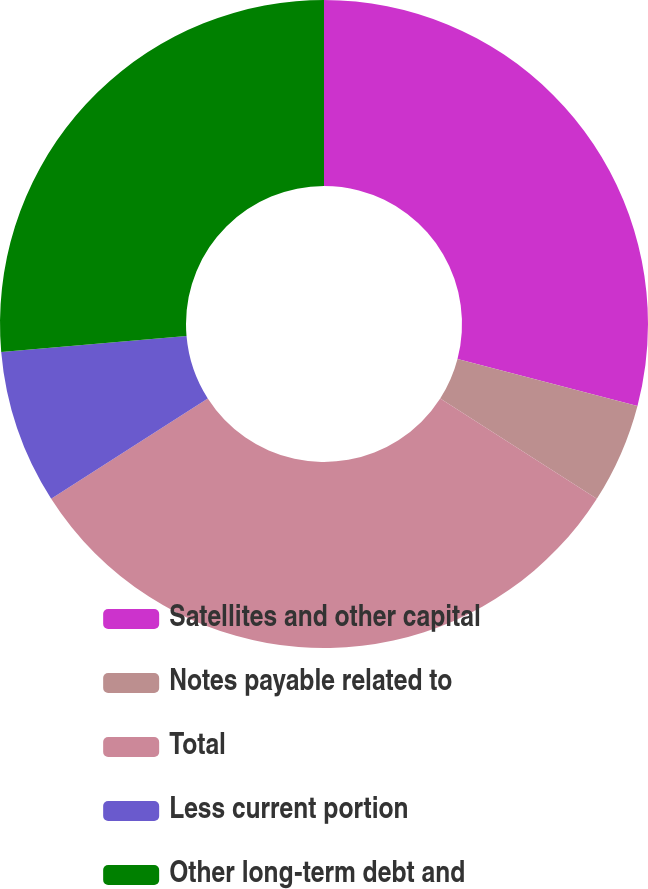<chart> <loc_0><loc_0><loc_500><loc_500><pie_chart><fcel>Satellites and other capital<fcel>Notes payable related to<fcel>Total<fcel>Less current portion<fcel>Other long-term debt and<nl><fcel>29.07%<fcel>5.0%<fcel>31.87%<fcel>7.69%<fcel>26.38%<nl></chart> 